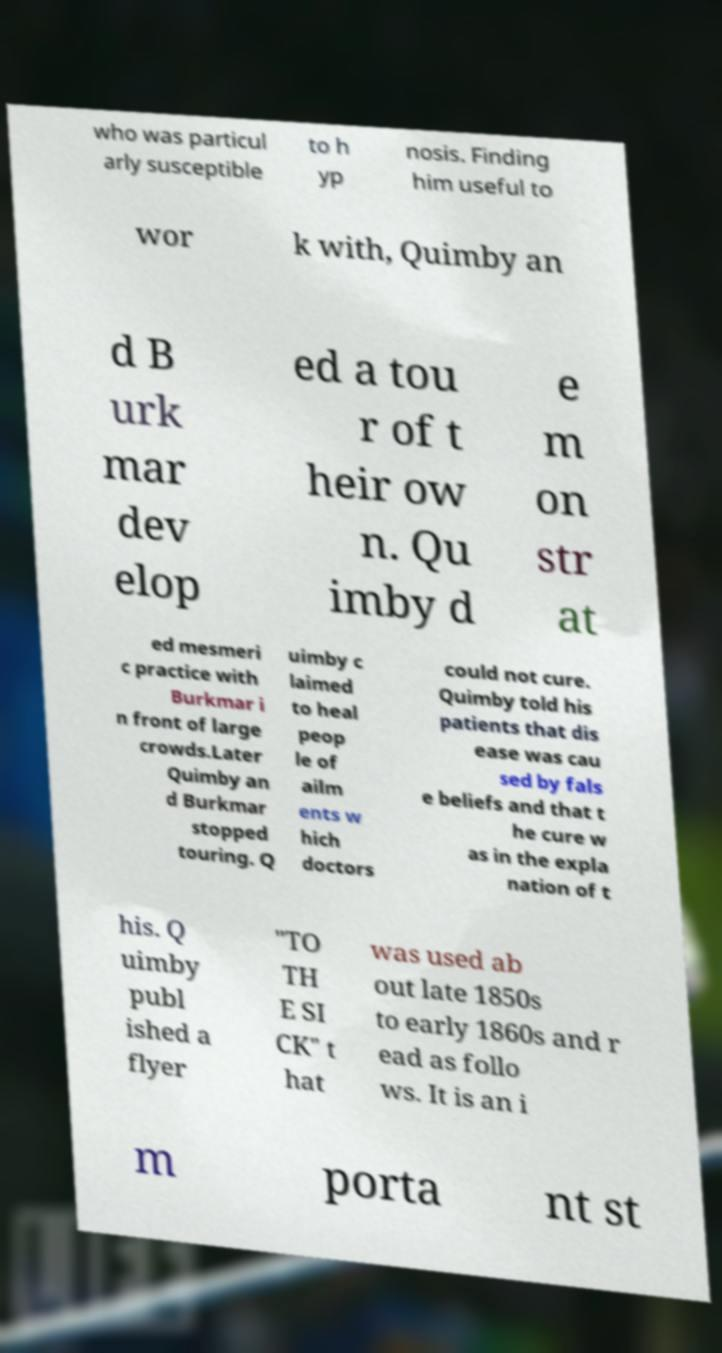I need the written content from this picture converted into text. Can you do that? who was particul arly susceptible to h yp nosis. Finding him useful to wor k with, Quimby an d B urk mar dev elop ed a tou r of t heir ow n. Qu imby d e m on str at ed mesmeri c practice with Burkmar i n front of large crowds.Later Quimby an d Burkmar stopped touring. Q uimby c laimed to heal peop le of ailm ents w hich doctors could not cure. Quimby told his patients that dis ease was cau sed by fals e beliefs and that t he cure w as in the expla nation of t his. Q uimby publ ished a flyer "TO TH E SI CK" t hat was used ab out late 1850s to early 1860s and r ead as follo ws. It is an i m porta nt st 